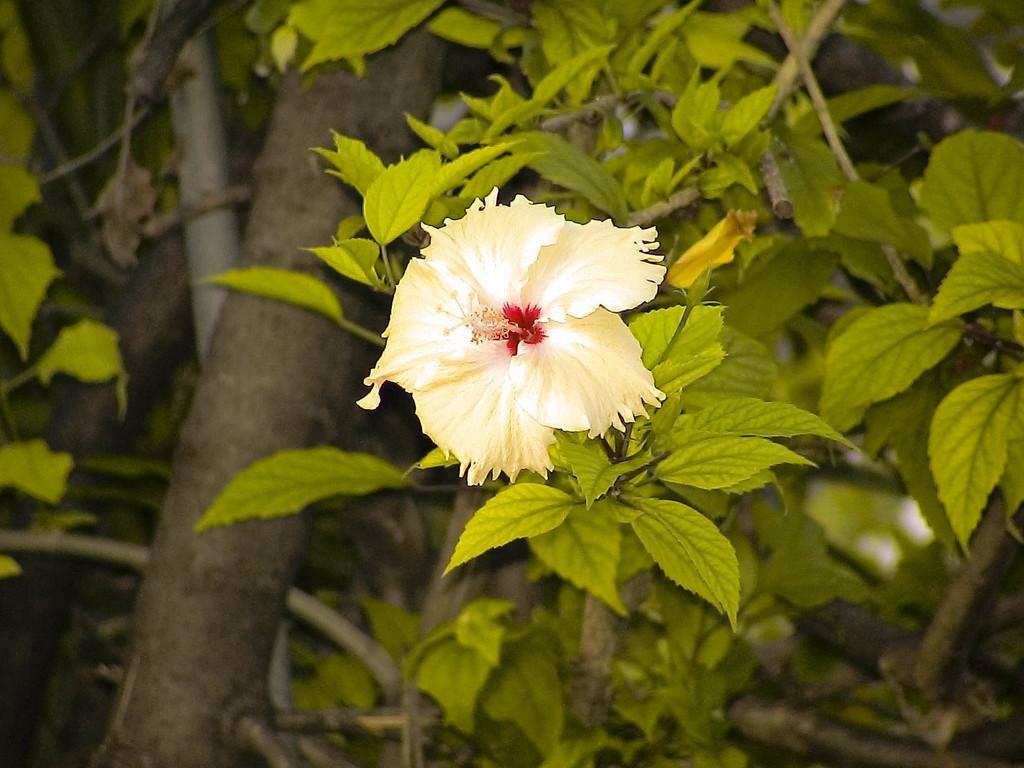Could you give a brief overview of what you see in this image? In the image there is a flower to the branch of a tree. 